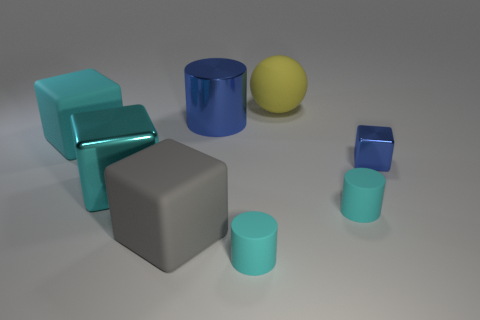Add 1 cyan matte cubes. How many objects exist? 9 Subtract all spheres. How many objects are left? 7 Add 1 metallic blocks. How many metallic blocks are left? 3 Add 8 large rubber cylinders. How many large rubber cylinders exist? 8 Subtract 0 purple cylinders. How many objects are left? 8 Subtract all large gray things. Subtract all small blue metal objects. How many objects are left? 6 